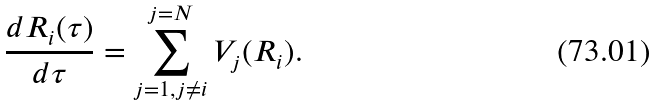<formula> <loc_0><loc_0><loc_500><loc_500>\frac { d { R } _ { i } ( \tau ) } { d \tau } = \sum _ { j = 1 , j \neq i } ^ { j = N } { V } _ { j } ( { R } _ { i } ) .</formula> 